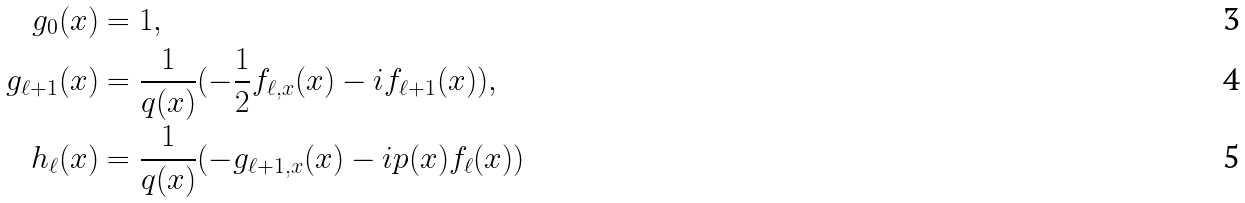Convert formula to latex. <formula><loc_0><loc_0><loc_500><loc_500>g _ { 0 } ( x ) & = 1 , \\ g _ { \ell + 1 } ( x ) & = \frac { 1 } { q ( x ) } ( - \frac { 1 } { 2 } f _ { \ell , x } ( x ) - i f _ { \ell + 1 } ( x ) ) , \\ h _ { \ell } ( x ) & = \frac { 1 } { q ( x ) } ( - g _ { \ell + 1 , x } ( x ) - i p ( x ) f _ { \ell } ( x ) )</formula> 